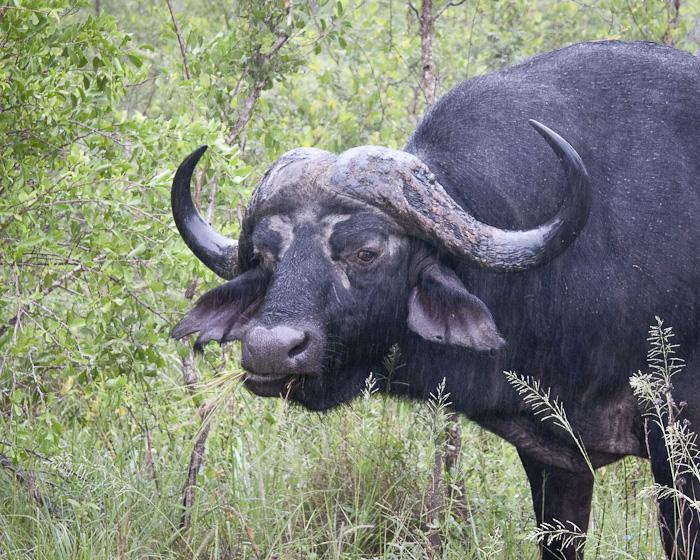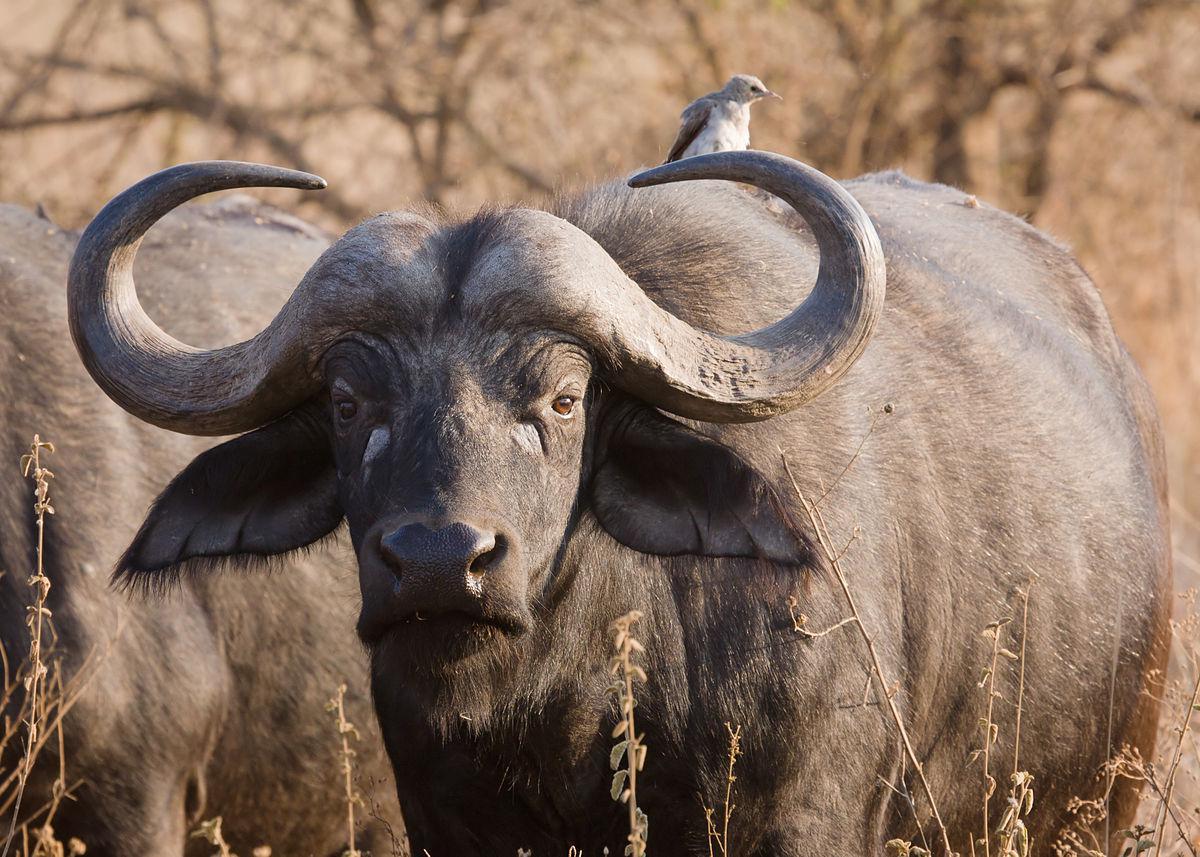The first image is the image on the left, the second image is the image on the right. Examine the images to the left and right. Is the description "An image features a camera-facing water buffalo with a bird perched on it." accurate? Answer yes or no. Yes. The first image is the image on the left, the second image is the image on the right. Examine the images to the left and right. Is the description "The left and right image contains the same number of long horned bull looking forward." accurate? Answer yes or no. Yes. The first image is the image on the left, the second image is the image on the right. Evaluate the accuracy of this statement regarding the images: "Each image contains one water buffalo in the foreground who is looking directly ahead at the camera.". Is it true? Answer yes or no. No. The first image is the image on the left, the second image is the image on the right. For the images displayed, is the sentence "At least one bird is landing or on a water buffalo." factually correct? Answer yes or no. Yes. 